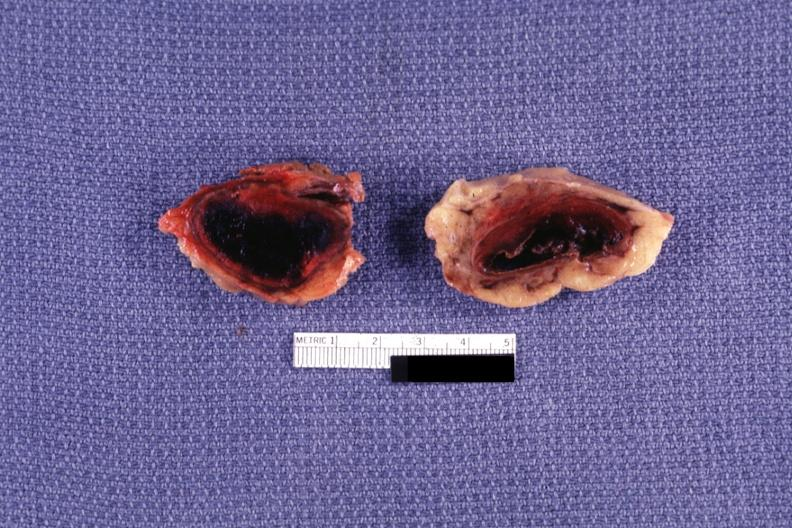does this image show sectioned glands with obvious hemorrhage?
Answer the question using a single word or phrase. Yes 